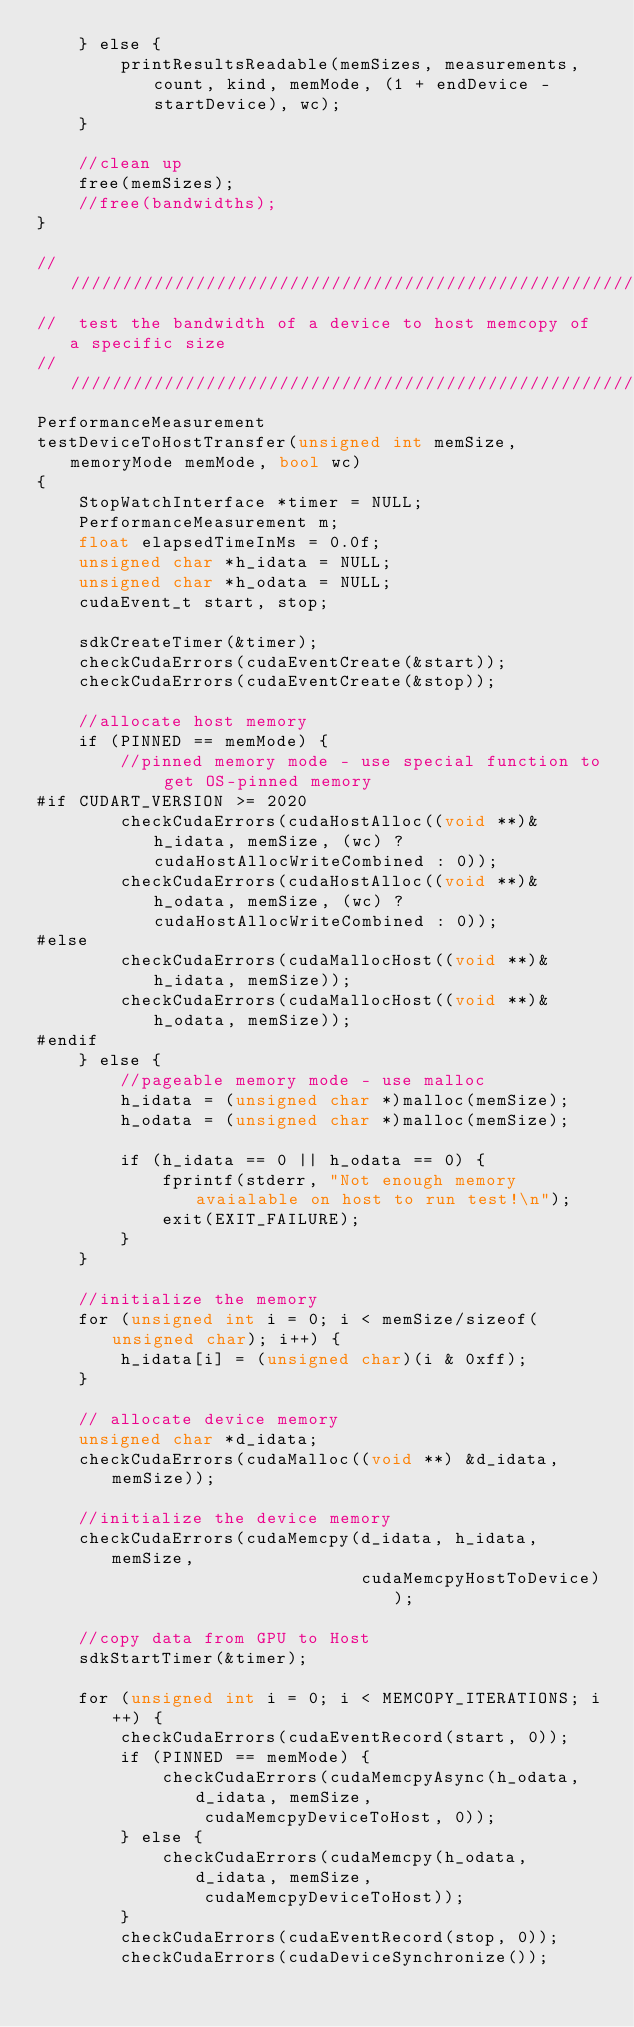Convert code to text. <code><loc_0><loc_0><loc_500><loc_500><_Cuda_>    } else {
        printResultsReadable(memSizes, measurements, count, kind, memMode, (1 + endDevice - startDevice), wc);
    }

    //clean up
    free(memSizes);
    //free(bandwidths);
}

///////////////////////////////////////////////////////////////////////////////
//  test the bandwidth of a device to host memcopy of a specific size
///////////////////////////////////////////////////////////////////////////////
PerformanceMeasurement
testDeviceToHostTransfer(unsigned int memSize, memoryMode memMode, bool wc)
{
    StopWatchInterface *timer = NULL;
    PerformanceMeasurement m;
    float elapsedTimeInMs = 0.0f;
    unsigned char *h_idata = NULL;
    unsigned char *h_odata = NULL;
    cudaEvent_t start, stop;

    sdkCreateTimer(&timer);
    checkCudaErrors(cudaEventCreate(&start));
    checkCudaErrors(cudaEventCreate(&stop));

    //allocate host memory
    if (PINNED == memMode) {
        //pinned memory mode - use special function to get OS-pinned memory
#if CUDART_VERSION >= 2020
        checkCudaErrors(cudaHostAlloc((void **)&h_idata, memSize, (wc) ? cudaHostAllocWriteCombined : 0));
        checkCudaErrors(cudaHostAlloc((void **)&h_odata, memSize, (wc) ? cudaHostAllocWriteCombined : 0));
#else
        checkCudaErrors(cudaMallocHost((void **)&h_idata, memSize));
        checkCudaErrors(cudaMallocHost((void **)&h_odata, memSize));
#endif
    } else {
        //pageable memory mode - use malloc
        h_idata = (unsigned char *)malloc(memSize);
        h_odata = (unsigned char *)malloc(memSize);

        if (h_idata == 0 || h_odata == 0) {
            fprintf(stderr, "Not enough memory avaialable on host to run test!\n");
            exit(EXIT_FAILURE);
        }
    }

    //initialize the memory
    for (unsigned int i = 0; i < memSize/sizeof(unsigned char); i++) {
        h_idata[i] = (unsigned char)(i & 0xff);
    }

    // allocate device memory
    unsigned char *d_idata;
    checkCudaErrors(cudaMalloc((void **) &d_idata, memSize));

    //initialize the device memory
    checkCudaErrors(cudaMemcpy(d_idata, h_idata, memSize,
                               cudaMemcpyHostToDevice));

    //copy data from GPU to Host
    sdkStartTimer(&timer);

	for (unsigned int i = 0; i < MEMCOPY_ITERATIONS; i++) {
		checkCudaErrors(cudaEventRecord(start, 0));
		if (PINNED == memMode) {
			checkCudaErrors(cudaMemcpyAsync(h_odata, d_idata, memSize,
				cudaMemcpyDeviceToHost, 0));
		} else {
			checkCudaErrors(cudaMemcpy(h_odata, d_idata, memSize,
				cudaMemcpyDeviceToHost));
		}
		checkCudaErrors(cudaEventRecord(stop, 0));
		checkCudaErrors(cudaDeviceSynchronize());</code> 